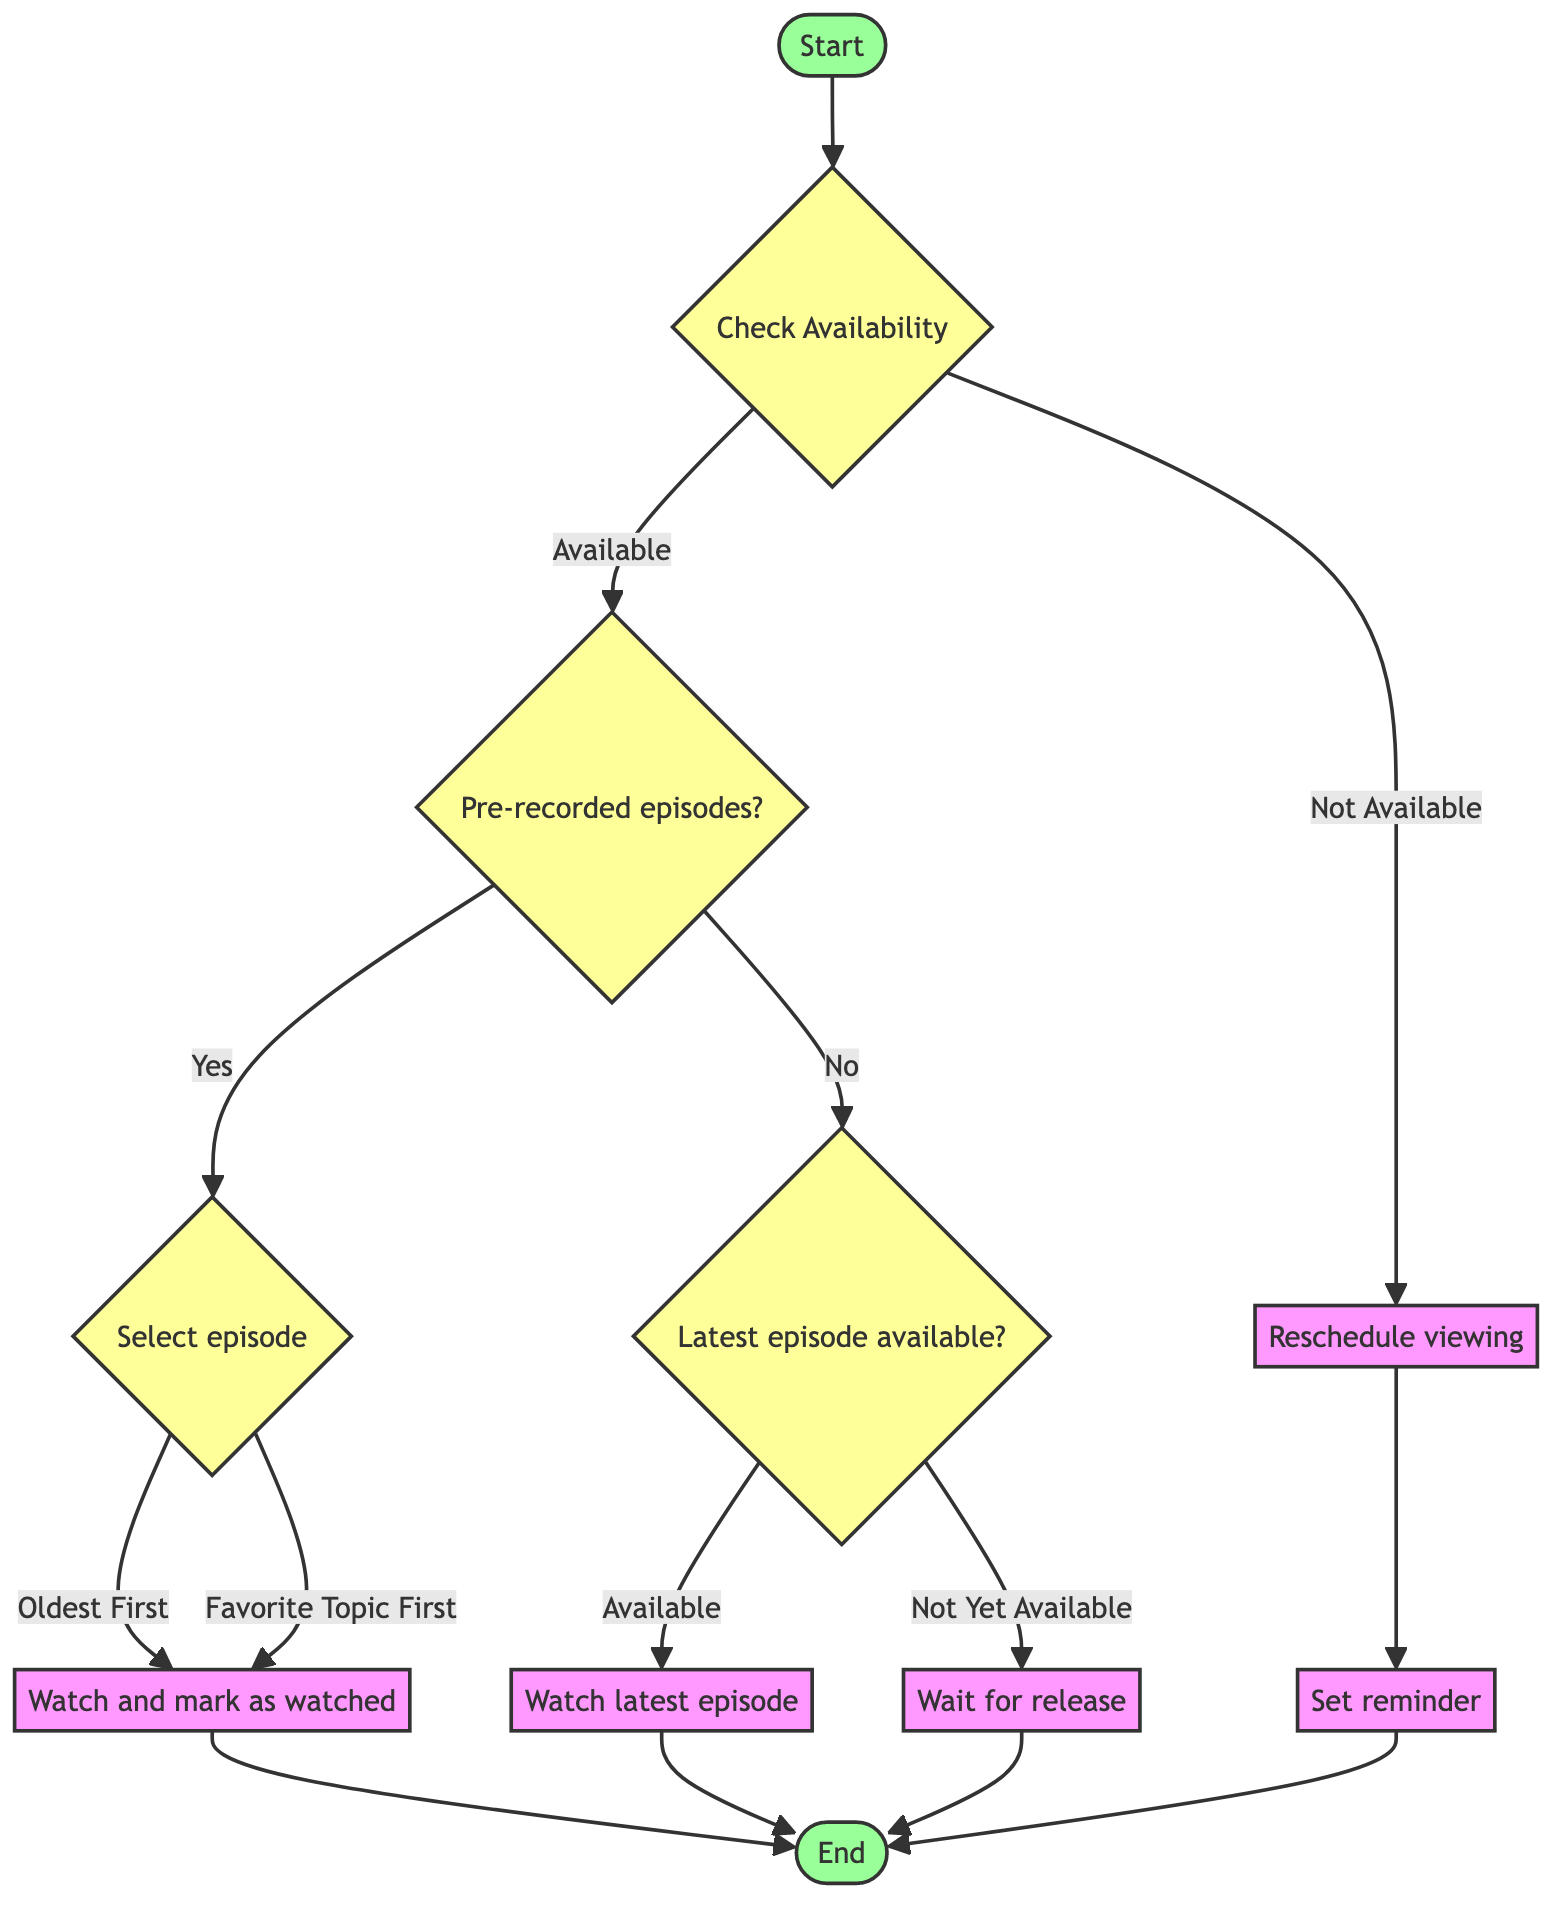What is the first node in the flowchart? The flowchart starts at the "Start" node, which is indicated as the entry point of the diagram.
Answer: Start How many options are available at the "Check Availability" node? The "Check Availability" node presents two options: "Available" and "Not Available," totaling two options.
Answer: 2 What action follows "Watch Latest Episode"? After "Watch Latest Episode," the flowchart connects directly to the "End" node, indicating the conclusion of that path.
Answer: End If episodes are unavailable, what is the action to take? If episodes are unavailable, you proceed to "Reschedule Watching," as indicated by the connection stemming from the "Check Availability" node.
Answer: Reschedule Watching What action is taken when there are pre-recorded episodes? If there are pre-recorded episodes, the next step is "Prioritize Backlog," which is the action taken based on the evaluation at the "Evaluate Episode Options" node.
Answer: Prioritize Backlog What are the two criteria for selecting an episode from the backlog? The criteria for selecting an episode from the backlog are "Oldest First" and "Favorite Topic First," as indicated at the "Prioritize Backlog" node.
Answer: Oldest First, Favorite Topic First In which case would you wait for a release? You would wait for a release if the "Latest episode available?" check indicates "Not Yet Available," leading to the corresponding action.
Answer: Wait For Release What node leads to setting a reminder? The node that leads to setting a reminder is "Reschedule Watching," which provides the option to "Set Reminder" for better scheduling after checking availability.
Answer: Set Reminder Which node represents completing an episode? The node representing the completion of watching an episode is "Watch And Mark Completed," where users indicate they have finished watching that particular episode.
Answer: Watch And Mark Completed 